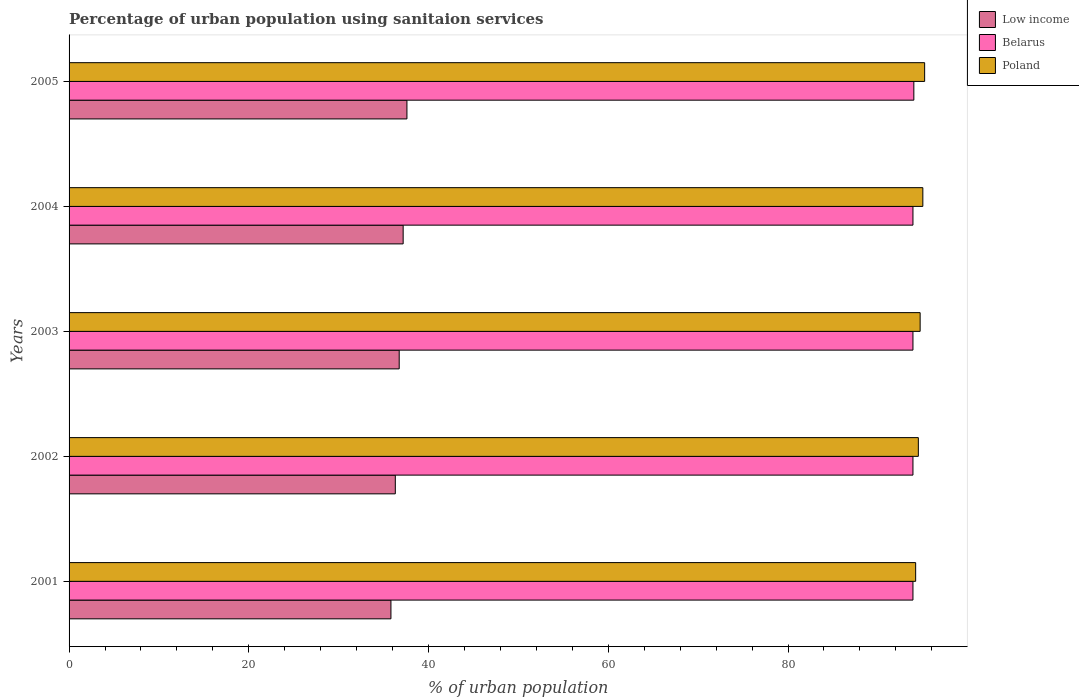How many groups of bars are there?
Ensure brevity in your answer.  5. Are the number of bars per tick equal to the number of legend labels?
Make the answer very short. Yes. Are the number of bars on each tick of the Y-axis equal?
Provide a short and direct response. Yes. How many bars are there on the 3rd tick from the top?
Keep it short and to the point. 3. How many bars are there on the 2nd tick from the bottom?
Your response must be concise. 3. What is the label of the 4th group of bars from the top?
Your answer should be very brief. 2002. What is the percentage of urban population using sanitaion services in Poland in 2003?
Your response must be concise. 94.7. Across all years, what is the maximum percentage of urban population using sanitaion services in Low income?
Give a very brief answer. 37.59. Across all years, what is the minimum percentage of urban population using sanitaion services in Belarus?
Ensure brevity in your answer.  93.9. What is the total percentage of urban population using sanitaion services in Low income in the graph?
Provide a short and direct response. 183.62. What is the difference between the percentage of urban population using sanitaion services in Low income in 2005 and the percentage of urban population using sanitaion services in Poland in 2003?
Offer a very short reply. -57.11. What is the average percentage of urban population using sanitaion services in Belarus per year?
Offer a very short reply. 93.92. In the year 2005, what is the difference between the percentage of urban population using sanitaion services in Poland and percentage of urban population using sanitaion services in Low income?
Ensure brevity in your answer.  57.61. What is the difference between the highest and the second highest percentage of urban population using sanitaion services in Poland?
Give a very brief answer. 0.2. What is the difference between the highest and the lowest percentage of urban population using sanitaion services in Low income?
Give a very brief answer. 1.78. In how many years, is the percentage of urban population using sanitaion services in Poland greater than the average percentage of urban population using sanitaion services in Poland taken over all years?
Offer a very short reply. 2. Is the sum of the percentage of urban population using sanitaion services in Belarus in 2001 and 2002 greater than the maximum percentage of urban population using sanitaion services in Low income across all years?
Provide a short and direct response. Yes. What does the 2nd bar from the top in 2005 represents?
Your response must be concise. Belarus. What does the 3rd bar from the bottom in 2003 represents?
Offer a terse response. Poland. How many bars are there?
Keep it short and to the point. 15. Are all the bars in the graph horizontal?
Give a very brief answer. Yes. Does the graph contain any zero values?
Ensure brevity in your answer.  No. How are the legend labels stacked?
Provide a short and direct response. Vertical. What is the title of the graph?
Offer a terse response. Percentage of urban population using sanitaion services. Does "Costa Rica" appear as one of the legend labels in the graph?
Offer a terse response. No. What is the label or title of the X-axis?
Ensure brevity in your answer.  % of urban population. What is the % of urban population in Low income in 2001?
Offer a very short reply. 35.81. What is the % of urban population of Belarus in 2001?
Give a very brief answer. 93.9. What is the % of urban population of Poland in 2001?
Give a very brief answer. 94.2. What is the % of urban population in Low income in 2002?
Your answer should be very brief. 36.3. What is the % of urban population in Belarus in 2002?
Your response must be concise. 93.9. What is the % of urban population in Poland in 2002?
Your answer should be compact. 94.5. What is the % of urban population in Low income in 2003?
Provide a succinct answer. 36.73. What is the % of urban population in Belarus in 2003?
Provide a short and direct response. 93.9. What is the % of urban population of Poland in 2003?
Ensure brevity in your answer.  94.7. What is the % of urban population of Low income in 2004?
Offer a very short reply. 37.17. What is the % of urban population of Belarus in 2004?
Give a very brief answer. 93.9. What is the % of urban population of Poland in 2004?
Provide a short and direct response. 95. What is the % of urban population of Low income in 2005?
Keep it short and to the point. 37.59. What is the % of urban population of Belarus in 2005?
Provide a short and direct response. 94. What is the % of urban population in Poland in 2005?
Your response must be concise. 95.2. Across all years, what is the maximum % of urban population in Low income?
Give a very brief answer. 37.59. Across all years, what is the maximum % of urban population in Belarus?
Offer a very short reply. 94. Across all years, what is the maximum % of urban population in Poland?
Provide a succinct answer. 95.2. Across all years, what is the minimum % of urban population of Low income?
Offer a very short reply. 35.81. Across all years, what is the minimum % of urban population of Belarus?
Your response must be concise. 93.9. Across all years, what is the minimum % of urban population in Poland?
Your answer should be very brief. 94.2. What is the total % of urban population in Low income in the graph?
Make the answer very short. 183.62. What is the total % of urban population of Belarus in the graph?
Provide a succinct answer. 469.6. What is the total % of urban population of Poland in the graph?
Provide a succinct answer. 473.6. What is the difference between the % of urban population in Low income in 2001 and that in 2002?
Keep it short and to the point. -0.49. What is the difference between the % of urban population of Low income in 2001 and that in 2003?
Offer a very short reply. -0.92. What is the difference between the % of urban population of Low income in 2001 and that in 2004?
Give a very brief answer. -1.36. What is the difference between the % of urban population in Belarus in 2001 and that in 2004?
Provide a succinct answer. 0. What is the difference between the % of urban population of Low income in 2001 and that in 2005?
Give a very brief answer. -1.78. What is the difference between the % of urban population of Poland in 2001 and that in 2005?
Offer a very short reply. -1. What is the difference between the % of urban population of Low income in 2002 and that in 2003?
Your answer should be very brief. -0.43. What is the difference between the % of urban population in Belarus in 2002 and that in 2003?
Offer a terse response. 0. What is the difference between the % of urban population in Low income in 2002 and that in 2004?
Keep it short and to the point. -0.87. What is the difference between the % of urban population of Poland in 2002 and that in 2004?
Make the answer very short. -0.5. What is the difference between the % of urban population in Low income in 2002 and that in 2005?
Provide a short and direct response. -1.29. What is the difference between the % of urban population in Low income in 2003 and that in 2004?
Your answer should be very brief. -0.44. What is the difference between the % of urban population in Low income in 2003 and that in 2005?
Provide a short and direct response. -0.86. What is the difference between the % of urban population in Belarus in 2003 and that in 2005?
Your answer should be compact. -0.1. What is the difference between the % of urban population in Poland in 2003 and that in 2005?
Your answer should be very brief. -0.5. What is the difference between the % of urban population of Low income in 2004 and that in 2005?
Make the answer very short. -0.42. What is the difference between the % of urban population in Poland in 2004 and that in 2005?
Offer a terse response. -0.2. What is the difference between the % of urban population in Low income in 2001 and the % of urban population in Belarus in 2002?
Give a very brief answer. -58.09. What is the difference between the % of urban population of Low income in 2001 and the % of urban population of Poland in 2002?
Your response must be concise. -58.69. What is the difference between the % of urban population in Low income in 2001 and the % of urban population in Belarus in 2003?
Provide a short and direct response. -58.09. What is the difference between the % of urban population in Low income in 2001 and the % of urban population in Poland in 2003?
Your answer should be very brief. -58.89. What is the difference between the % of urban population in Low income in 2001 and the % of urban population in Belarus in 2004?
Ensure brevity in your answer.  -58.09. What is the difference between the % of urban population of Low income in 2001 and the % of urban population of Poland in 2004?
Offer a very short reply. -59.19. What is the difference between the % of urban population in Belarus in 2001 and the % of urban population in Poland in 2004?
Offer a terse response. -1.1. What is the difference between the % of urban population of Low income in 2001 and the % of urban population of Belarus in 2005?
Your answer should be compact. -58.19. What is the difference between the % of urban population of Low income in 2001 and the % of urban population of Poland in 2005?
Your answer should be very brief. -59.39. What is the difference between the % of urban population of Low income in 2002 and the % of urban population of Belarus in 2003?
Make the answer very short. -57.6. What is the difference between the % of urban population of Low income in 2002 and the % of urban population of Poland in 2003?
Your answer should be compact. -58.4. What is the difference between the % of urban population of Low income in 2002 and the % of urban population of Belarus in 2004?
Provide a succinct answer. -57.6. What is the difference between the % of urban population of Low income in 2002 and the % of urban population of Poland in 2004?
Ensure brevity in your answer.  -58.7. What is the difference between the % of urban population in Low income in 2002 and the % of urban population in Belarus in 2005?
Provide a short and direct response. -57.7. What is the difference between the % of urban population of Low income in 2002 and the % of urban population of Poland in 2005?
Keep it short and to the point. -58.9. What is the difference between the % of urban population in Belarus in 2002 and the % of urban population in Poland in 2005?
Offer a terse response. -1.3. What is the difference between the % of urban population in Low income in 2003 and the % of urban population in Belarus in 2004?
Your answer should be very brief. -57.17. What is the difference between the % of urban population in Low income in 2003 and the % of urban population in Poland in 2004?
Your answer should be very brief. -58.27. What is the difference between the % of urban population of Low income in 2003 and the % of urban population of Belarus in 2005?
Make the answer very short. -57.27. What is the difference between the % of urban population of Low income in 2003 and the % of urban population of Poland in 2005?
Your response must be concise. -58.47. What is the difference between the % of urban population in Low income in 2004 and the % of urban population in Belarus in 2005?
Your response must be concise. -56.83. What is the difference between the % of urban population of Low income in 2004 and the % of urban population of Poland in 2005?
Your answer should be compact. -58.03. What is the difference between the % of urban population of Belarus in 2004 and the % of urban population of Poland in 2005?
Ensure brevity in your answer.  -1.3. What is the average % of urban population of Low income per year?
Keep it short and to the point. 36.72. What is the average % of urban population of Belarus per year?
Make the answer very short. 93.92. What is the average % of urban population in Poland per year?
Provide a short and direct response. 94.72. In the year 2001, what is the difference between the % of urban population of Low income and % of urban population of Belarus?
Your response must be concise. -58.09. In the year 2001, what is the difference between the % of urban population of Low income and % of urban population of Poland?
Ensure brevity in your answer.  -58.39. In the year 2002, what is the difference between the % of urban population in Low income and % of urban population in Belarus?
Make the answer very short. -57.6. In the year 2002, what is the difference between the % of urban population in Low income and % of urban population in Poland?
Ensure brevity in your answer.  -58.2. In the year 2003, what is the difference between the % of urban population in Low income and % of urban population in Belarus?
Offer a very short reply. -57.17. In the year 2003, what is the difference between the % of urban population of Low income and % of urban population of Poland?
Provide a short and direct response. -57.97. In the year 2004, what is the difference between the % of urban population in Low income and % of urban population in Belarus?
Make the answer very short. -56.73. In the year 2004, what is the difference between the % of urban population of Low income and % of urban population of Poland?
Offer a terse response. -57.83. In the year 2005, what is the difference between the % of urban population of Low income and % of urban population of Belarus?
Your answer should be compact. -56.41. In the year 2005, what is the difference between the % of urban population in Low income and % of urban population in Poland?
Your answer should be compact. -57.61. What is the ratio of the % of urban population in Low income in 2001 to that in 2002?
Provide a short and direct response. 0.99. What is the ratio of the % of urban population in Low income in 2001 to that in 2003?
Your answer should be compact. 0.97. What is the ratio of the % of urban population of Low income in 2001 to that in 2004?
Your answer should be compact. 0.96. What is the ratio of the % of urban population in Belarus in 2001 to that in 2004?
Make the answer very short. 1. What is the ratio of the % of urban population in Poland in 2001 to that in 2004?
Keep it short and to the point. 0.99. What is the ratio of the % of urban population of Low income in 2001 to that in 2005?
Your answer should be compact. 0.95. What is the ratio of the % of urban population in Low income in 2002 to that in 2004?
Make the answer very short. 0.98. What is the ratio of the % of urban population in Poland in 2002 to that in 2004?
Your response must be concise. 0.99. What is the ratio of the % of urban population in Low income in 2002 to that in 2005?
Your answer should be compact. 0.97. What is the ratio of the % of urban population of Belarus in 2003 to that in 2004?
Offer a very short reply. 1. What is the ratio of the % of urban population in Poland in 2003 to that in 2004?
Your answer should be very brief. 1. What is the ratio of the % of urban population in Low income in 2003 to that in 2005?
Offer a terse response. 0.98. What is the ratio of the % of urban population of Belarus in 2003 to that in 2005?
Offer a very short reply. 1. What is the difference between the highest and the second highest % of urban population of Low income?
Keep it short and to the point. 0.42. What is the difference between the highest and the second highest % of urban population in Poland?
Keep it short and to the point. 0.2. What is the difference between the highest and the lowest % of urban population in Low income?
Offer a terse response. 1.78. 